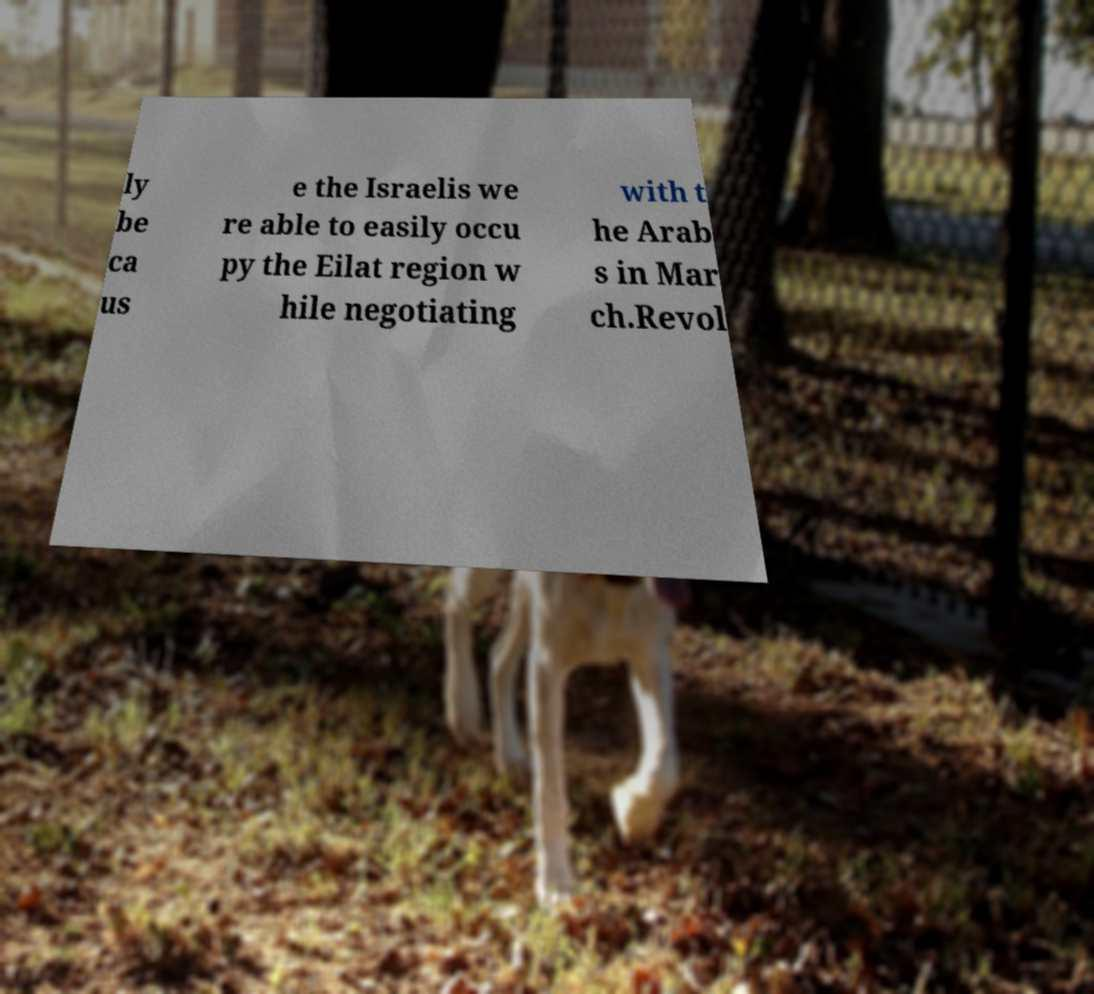Could you assist in decoding the text presented in this image and type it out clearly? ly be ca us e the Israelis we re able to easily occu py the Eilat region w hile negotiating with t he Arab s in Mar ch.Revol 